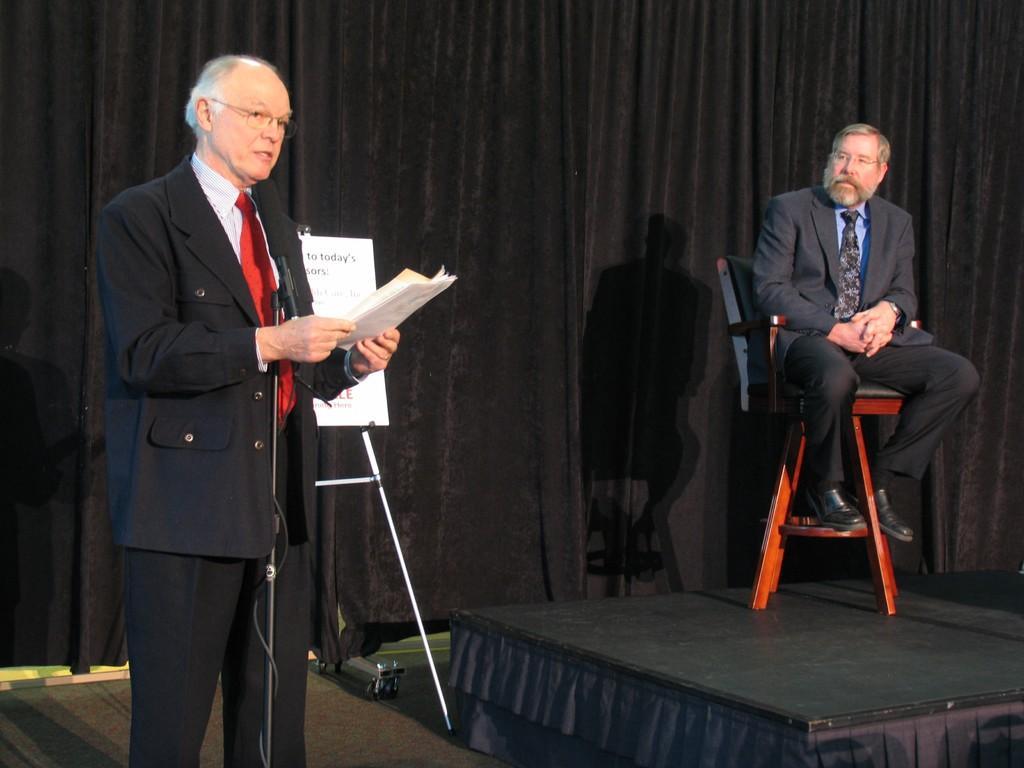Could you give a brief overview of what you see in this image? in this image i can see a black color curtain on the back ground and there is a person on the left side stand in front of a mike and he holding a papers on his hand and another person on the right side sitting on the chair. 